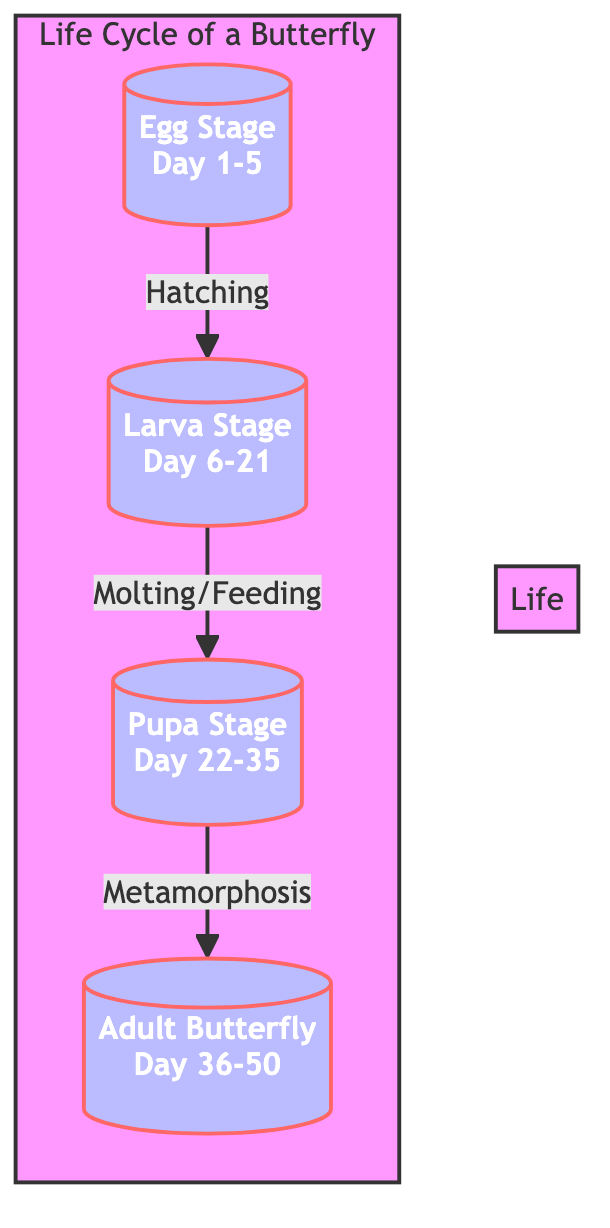What's the first stage of the butterfly's life cycle? The diagram shows the stages of the butterfly's life cycle starting with the egg stage. This is labeled as the first stage, indicating where the cycle begins.
Answer: Egg Stage How long is the larva stage? According to the diagram, the larva stage is indicated as lasting from Day 6 to Day 21, which totals 15 days.
Answer: 15 days What process occurs between the larva and pupa stages? The diagram illustrates that the transition from the larva stage to the pupa stage is marked by molting and feeding, which are key processes in this transition.
Answer: Molting/Feeding How many stages are there in the life cycle of a butterfly? By reviewing the diagram, there are a total of four stages listed (Egg, Larva, Pupa, Adult Butterfly), thus the count confirms the total.
Answer: 4 What is the last stage in the butterfly's life cycle? The final stage depicted in the diagram is the Adult Butterfly, indicated as the last point in the progression of life stages.
Answer: Adult Butterfly During which days does the pupa stage occur? The diagram specifies that the pupa stage occurs from Day 22 to Day 35, providing clear details about the duration of this stage.
Answer: Day 22-35 What is the total duration of the butterfly's life cycle as indicated in the diagram? By analyzing the durations of all stages, from Day 1 to Day 50, the total life cycle duration can be concluded as 50 days.
Answer: 50 days Which stage follows the pupa stage? The diagram clearly shows that the adult butterfly stage follows the pupa stage, as indicated by the arrow that connects these two stages.
Answer: Adult Butterfly What important transformation occurs during the transition from the pupa to the adult butterfly? The diagram notes that metamorphosis is the critical transformation process that occurs during this transition, highlighting the significant biological change.
Answer: Metamorphosis 